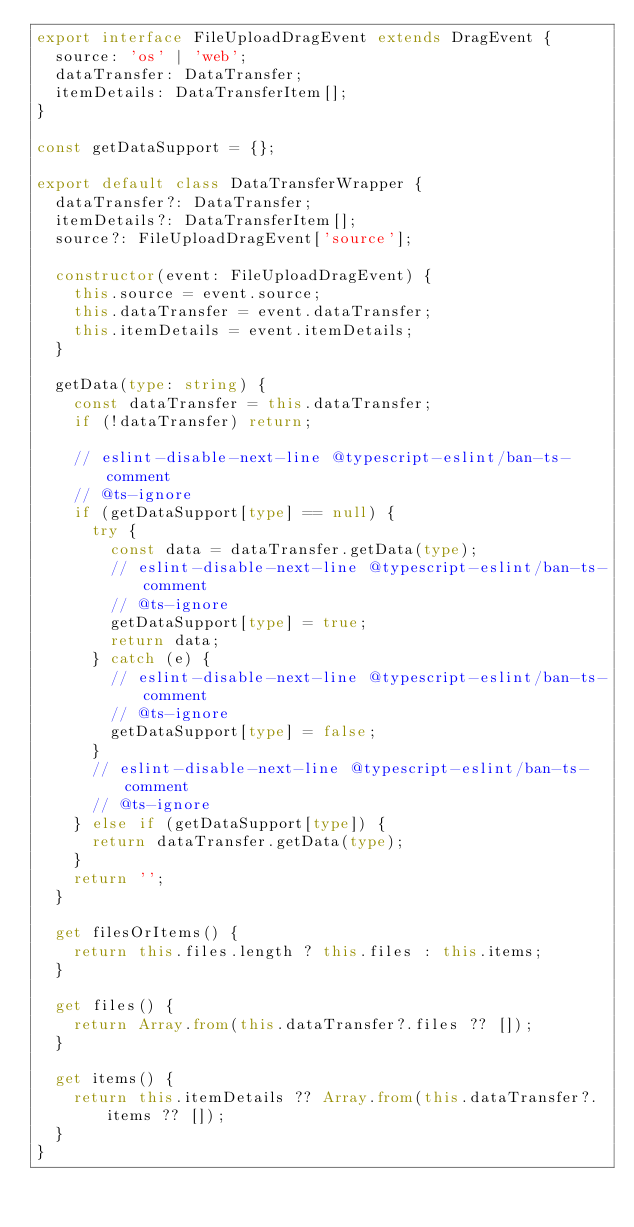<code> <loc_0><loc_0><loc_500><loc_500><_TypeScript_>export interface FileUploadDragEvent extends DragEvent {
  source: 'os' | 'web';
  dataTransfer: DataTransfer;
  itemDetails: DataTransferItem[];
}

const getDataSupport = {};

export default class DataTransferWrapper {
  dataTransfer?: DataTransfer;
  itemDetails?: DataTransferItem[];
  source?: FileUploadDragEvent['source'];

  constructor(event: FileUploadDragEvent) {
    this.source = event.source;
    this.dataTransfer = event.dataTransfer;
    this.itemDetails = event.itemDetails;
  }

  getData(type: string) {
    const dataTransfer = this.dataTransfer;
    if (!dataTransfer) return;

    // eslint-disable-next-line @typescript-eslint/ban-ts-comment
    // @ts-ignore
    if (getDataSupport[type] == null) {
      try {
        const data = dataTransfer.getData(type);
        // eslint-disable-next-line @typescript-eslint/ban-ts-comment
        // @ts-ignore
        getDataSupport[type] = true;
        return data;
      } catch (e) {
        // eslint-disable-next-line @typescript-eslint/ban-ts-comment
        // @ts-ignore
        getDataSupport[type] = false;
      }
      // eslint-disable-next-line @typescript-eslint/ban-ts-comment
      // @ts-ignore
    } else if (getDataSupport[type]) {
      return dataTransfer.getData(type);
    }
    return '';
  }

  get filesOrItems() {
    return this.files.length ? this.files : this.items;
  }

  get files() {
    return Array.from(this.dataTransfer?.files ?? []);
  }

  get items() {
    return this.itemDetails ?? Array.from(this.dataTransfer?.items ?? []);
  }
}
</code> 